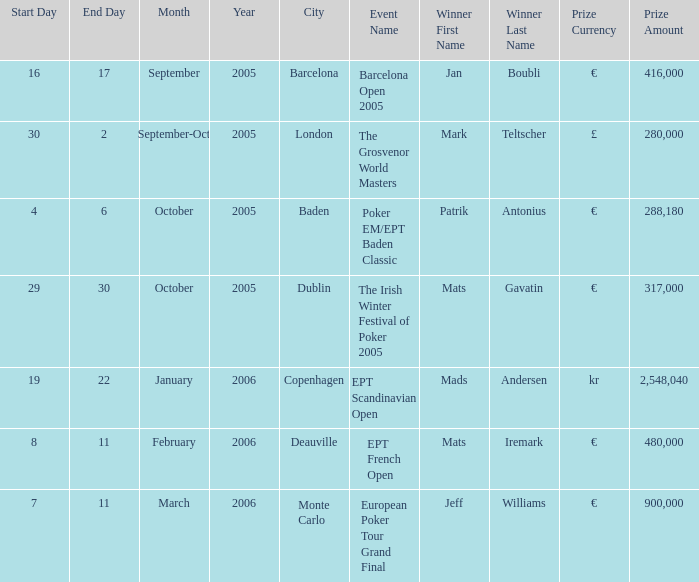What city was the event in when Patrik Antonius won? Baden. 